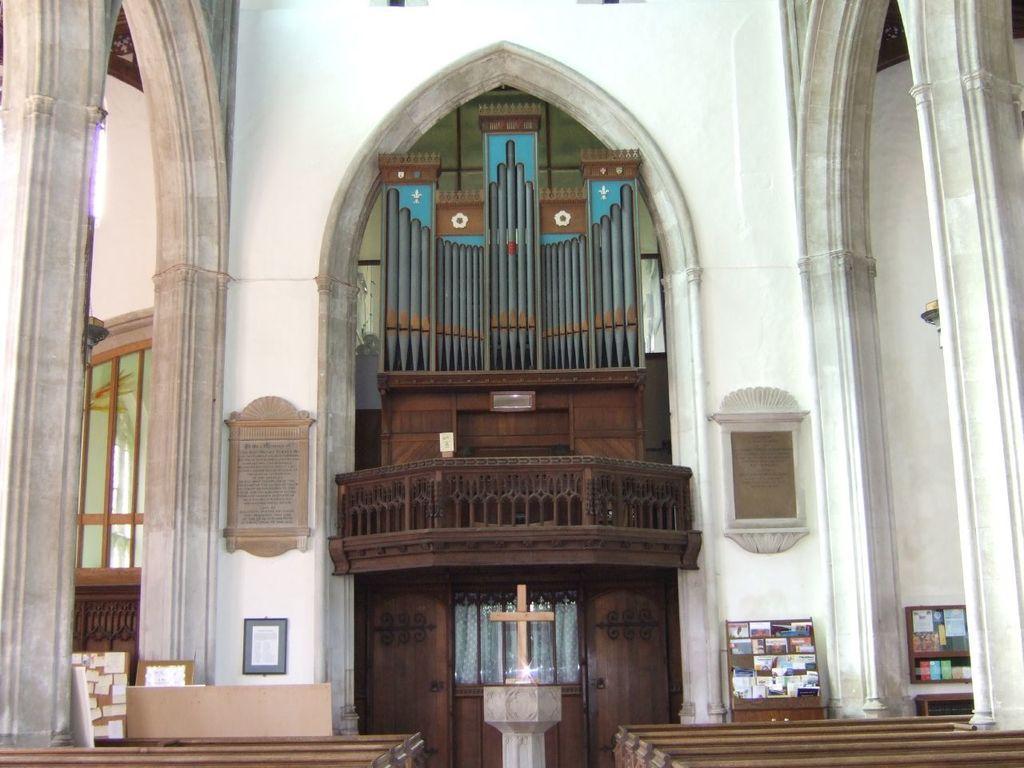Describe this image in one or two sentences. In this image we can see an inside view of the church, there are wooden objects towards the bottom of the image, there are pillars, there is a window, there are boards, there are objects on the boards, there is a wooden wall, there is a cloth. 